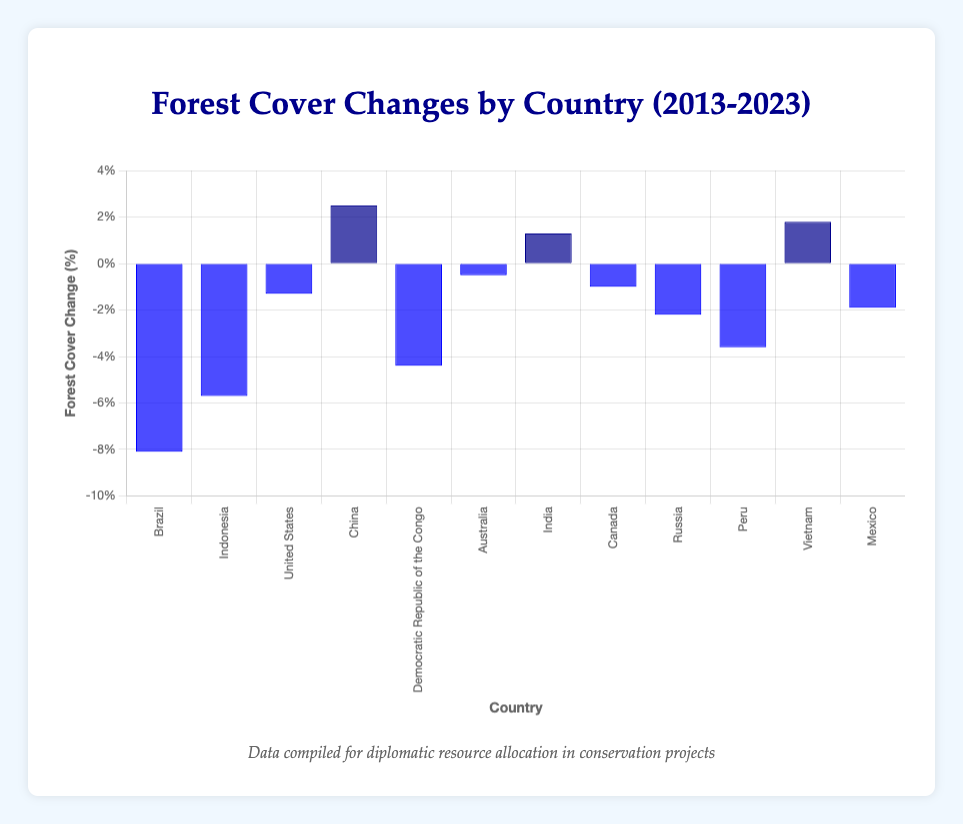What is the country with the largest decrease in forest cover percentage from 2013 to 2023? To find the country with the largest decrease, we look for the country with the most negative value in forest cover change percentage. Brazil shows a -8.1% change, which is the most negative value.
Answer: Brazil Which countries show a positive change in forest cover percentage? By identifying the bars with positive heights in the chart, we can see that China (2.5%), India (1.3%), and Vietnam (1.8%) have positive changes in forest cover.
Answer: China, India, Vietnam What is the combined forest cover change percentage for the countries showing an increase? Adding the forest cover change percentages of China (2.5%), India (1.3%), and Vietnam (1.8%) yields 2.5 + 1.3 + 1.8 = 5.6%.
Answer: 5.6% How does the forest cover change percentage of the United States compare to that of Mexico? The United States has a -1.3% change, while Mexico has a -1.9% change. Therefore, the United States has a lesser decrease compared to Mexico by -1.3% - (-1.9%) = 0.6%.
Answer: The United States has a lesser decrease by 0.6% Which country shows a greater decrease in forest cover, Peru or Indonesia, and by how much? Peru's forest cover change is -3.6%, and Indonesia's is -5.7%. Indonesia shows a greater decrease by -5.7% - (-3.6%) = -2.1%.
Answer: Indonesia by 2.1% What is the average forest cover change percentage for all countries listed? Summing all percentages: -8.1 + (-5.7) + (-1.3) + 2.5 + (-4.4) + (-0.5) + 1.3 + (-1.0) + (-2.2) + (-3.6) + 1.8 + (-1.9) = -23.1, and then dividing by the number of countries (12) gives -23.1 / 12 ≈ -1.93%.
Answer: -1.93% Which visual attribute distinguishes countries with an increase in forest cover from those with a decrease? The bars for countries with an increase in forest cover are colored dark blue, while those with a decrease are colored blue.
Answer: Bar color: dark blue for increase, blue for decrease What is the sum of the forest cover changes for Brazil and the Democratic Republic of the Congo? Adding the changes for Brazil (-8.1) and the Democratic Republic of the Congo (-4.4), we get -8.1 + (-4.4) = -12.5%.
Answer: -12.5% How many countries experienced a decrease in forest cover percentage? Counting the number of bars colored blue, we see that 9 countries experienced a decrease in forest cover.
Answer: 9 What is the difference in forest cover change percentage between the country with the highest increase and the country with the highest decrease? The highest increase is China with 2.5%, and the highest decrease is Brazil with -8.1%. The difference is 2.5 - (-8.1) = 10.6%.
Answer: 10.6% 